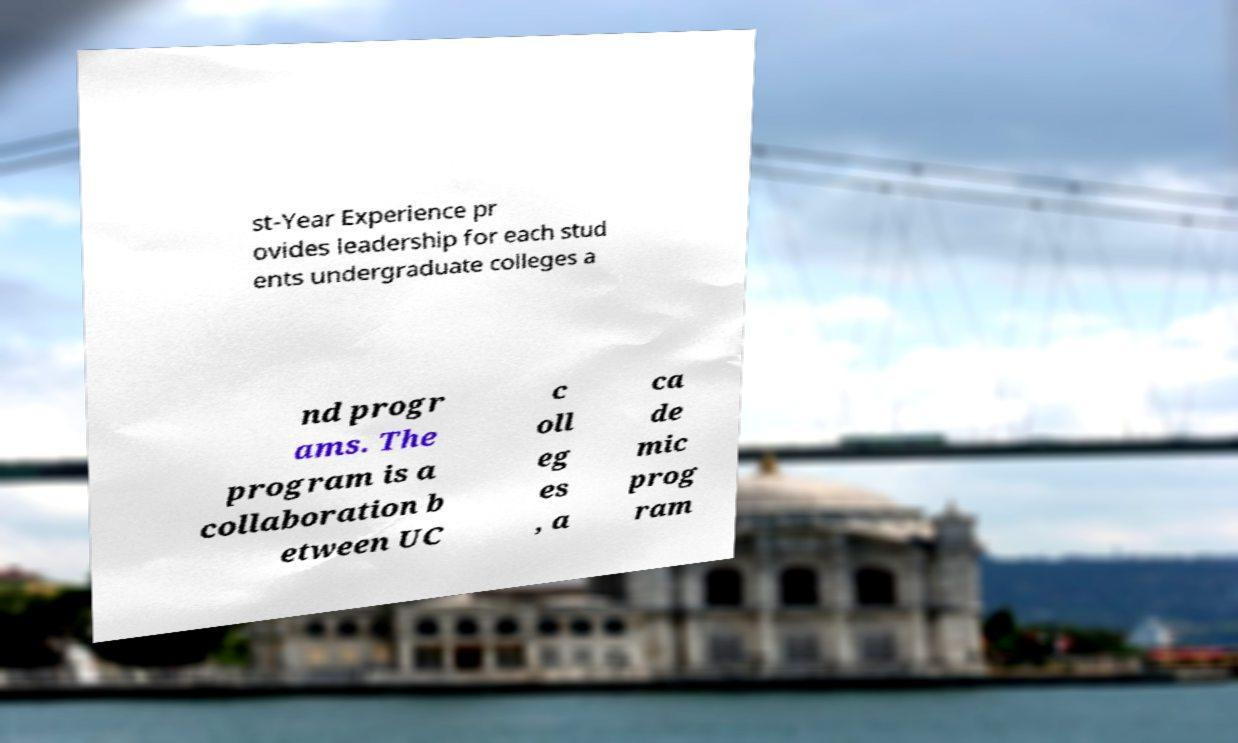Could you extract and type out the text from this image? st-Year Experience pr ovides leadership for each stud ents undergraduate colleges a nd progr ams. The program is a collaboration b etween UC c oll eg es , a ca de mic prog ram 